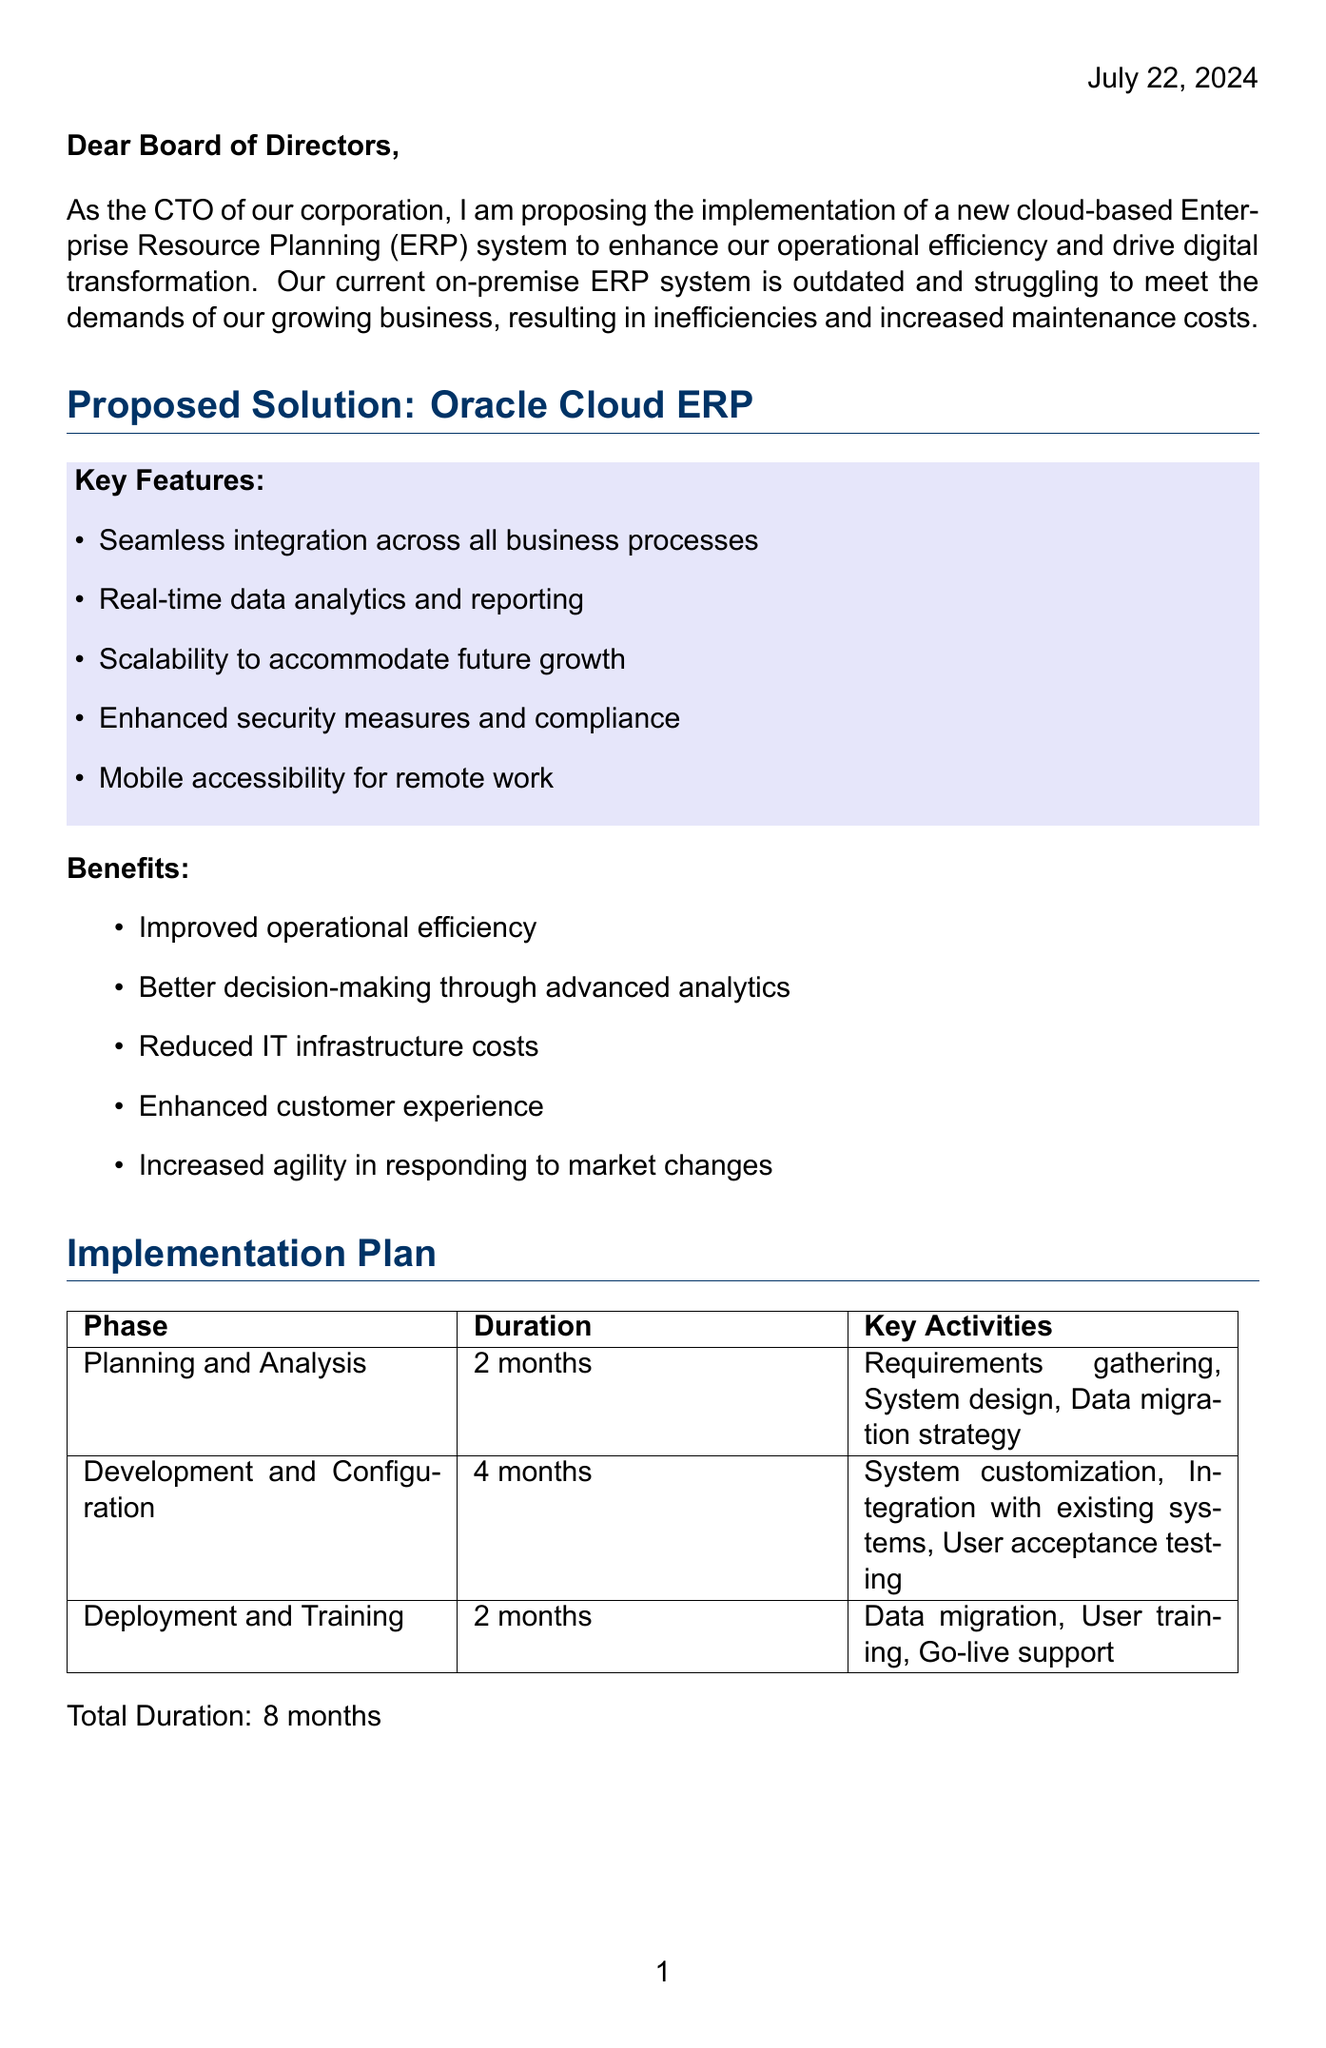What is the name of the proposed ERP system? The proposed ERP system is explicitly named in the document as the solution to current challenges in the corporation.
Answer: Oracle Cloud ERP What is the total duration for implementation? The total duration for the implementation phase is brought together from individual phases mentioned in the document.
Answer: 8 months What is the initial investment amount for training? The amount allocated for training as part of the initial investment is detailed in the cost analysis section.
Answer: $500,000 What is the expected annual savings from operational efficiency? The document specifies the expected annual savings attributed to operational efficiency, which is crucial for the ROI analysis.
Answer: $3,000,000 What is the recommended payback period for the investment? The payback period outlined in the ROI analysis indicates the time required to recover the initial investment and is a vital metric for decision-making.
Answer: 2.3 years What is one of the risks associated with the ERP implementation? The document lists potential risks to the implementation process, assisting in understanding challenges we may face.
Answer: Data migration challenges What are the key activities in the Development and Configuration phase? The activities in this phase are important for understanding the steps we need to take to customize the system effectively.
Answer: System customization, Integration with existing systems, User acceptance testing What is the total cost over five years? The total cost over five years is essential for budget planning and justifying the proposed investment in technology.
Answer: $14,500,000 What is the net benefit expected from the investment? The net benefit, indicating the financial gain from the investment after costs, is crucial for evaluating project viability.
Answer: $18,000,000 